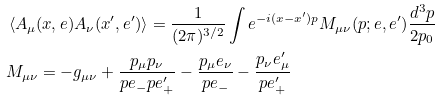<formula> <loc_0><loc_0><loc_500><loc_500>& \left \langle A _ { \mu } ( x , e ) A _ { \nu } ( x ^ { \prime } , e ^ { \prime } ) \right \rangle = \frac { 1 } { ( 2 \pi ) ^ { 3 / 2 } } \int e ^ { - i ( x - x ^ { \prime } ) p } M _ { \mu \nu } ( p ; e , e ^ { \prime } ) \frac { d ^ { 3 } p } { 2 p _ { 0 } } \\ & M _ { \mu \nu } = - g _ { \mu \nu } + \frac { p _ { \mu } p _ { \nu } } { p e _ { - } p e _ { + } ^ { \prime } } - \frac { p _ { \mu } e _ { \nu } } { p e _ { - } } - \frac { p _ { \nu } e _ { \mu } ^ { \prime } } { p e _ { + } ^ { \prime } }</formula> 